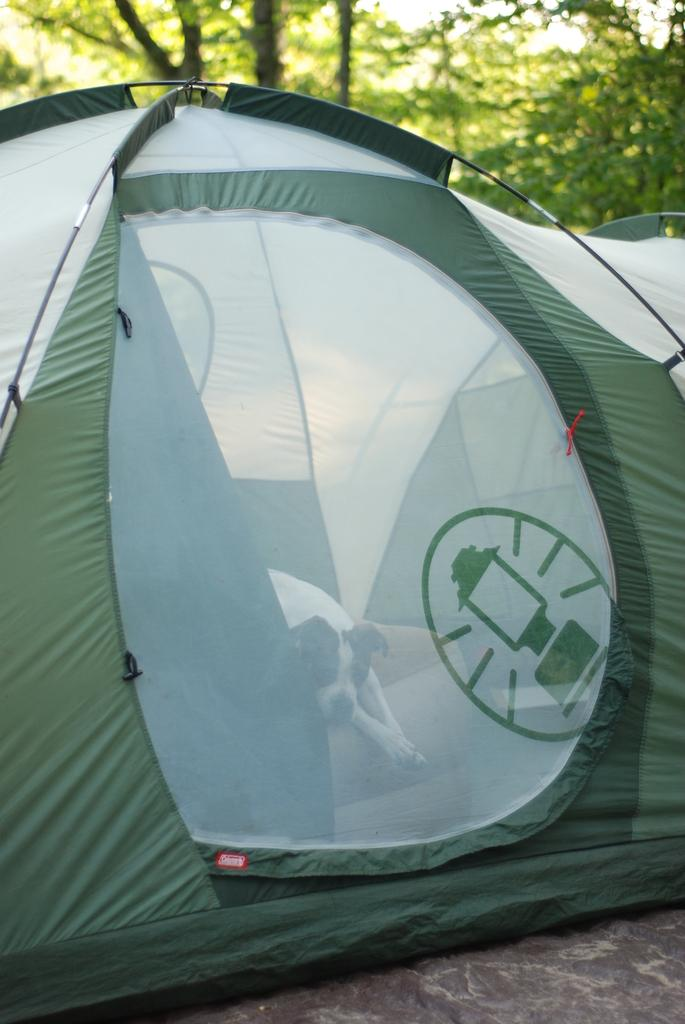What structure can be seen in the image? There is a tent in the image. What is inside the tent? There is a dog inside the tent. What type of natural environment is visible in the image? Trees and the sky are visible at the top of the image. What type of meat is being cooked outside the tent in the image? There is no meat or cooking activity present in the image. What type of dress is the dog wearing inside the tent? The dog is not wearing any dress in the image. 